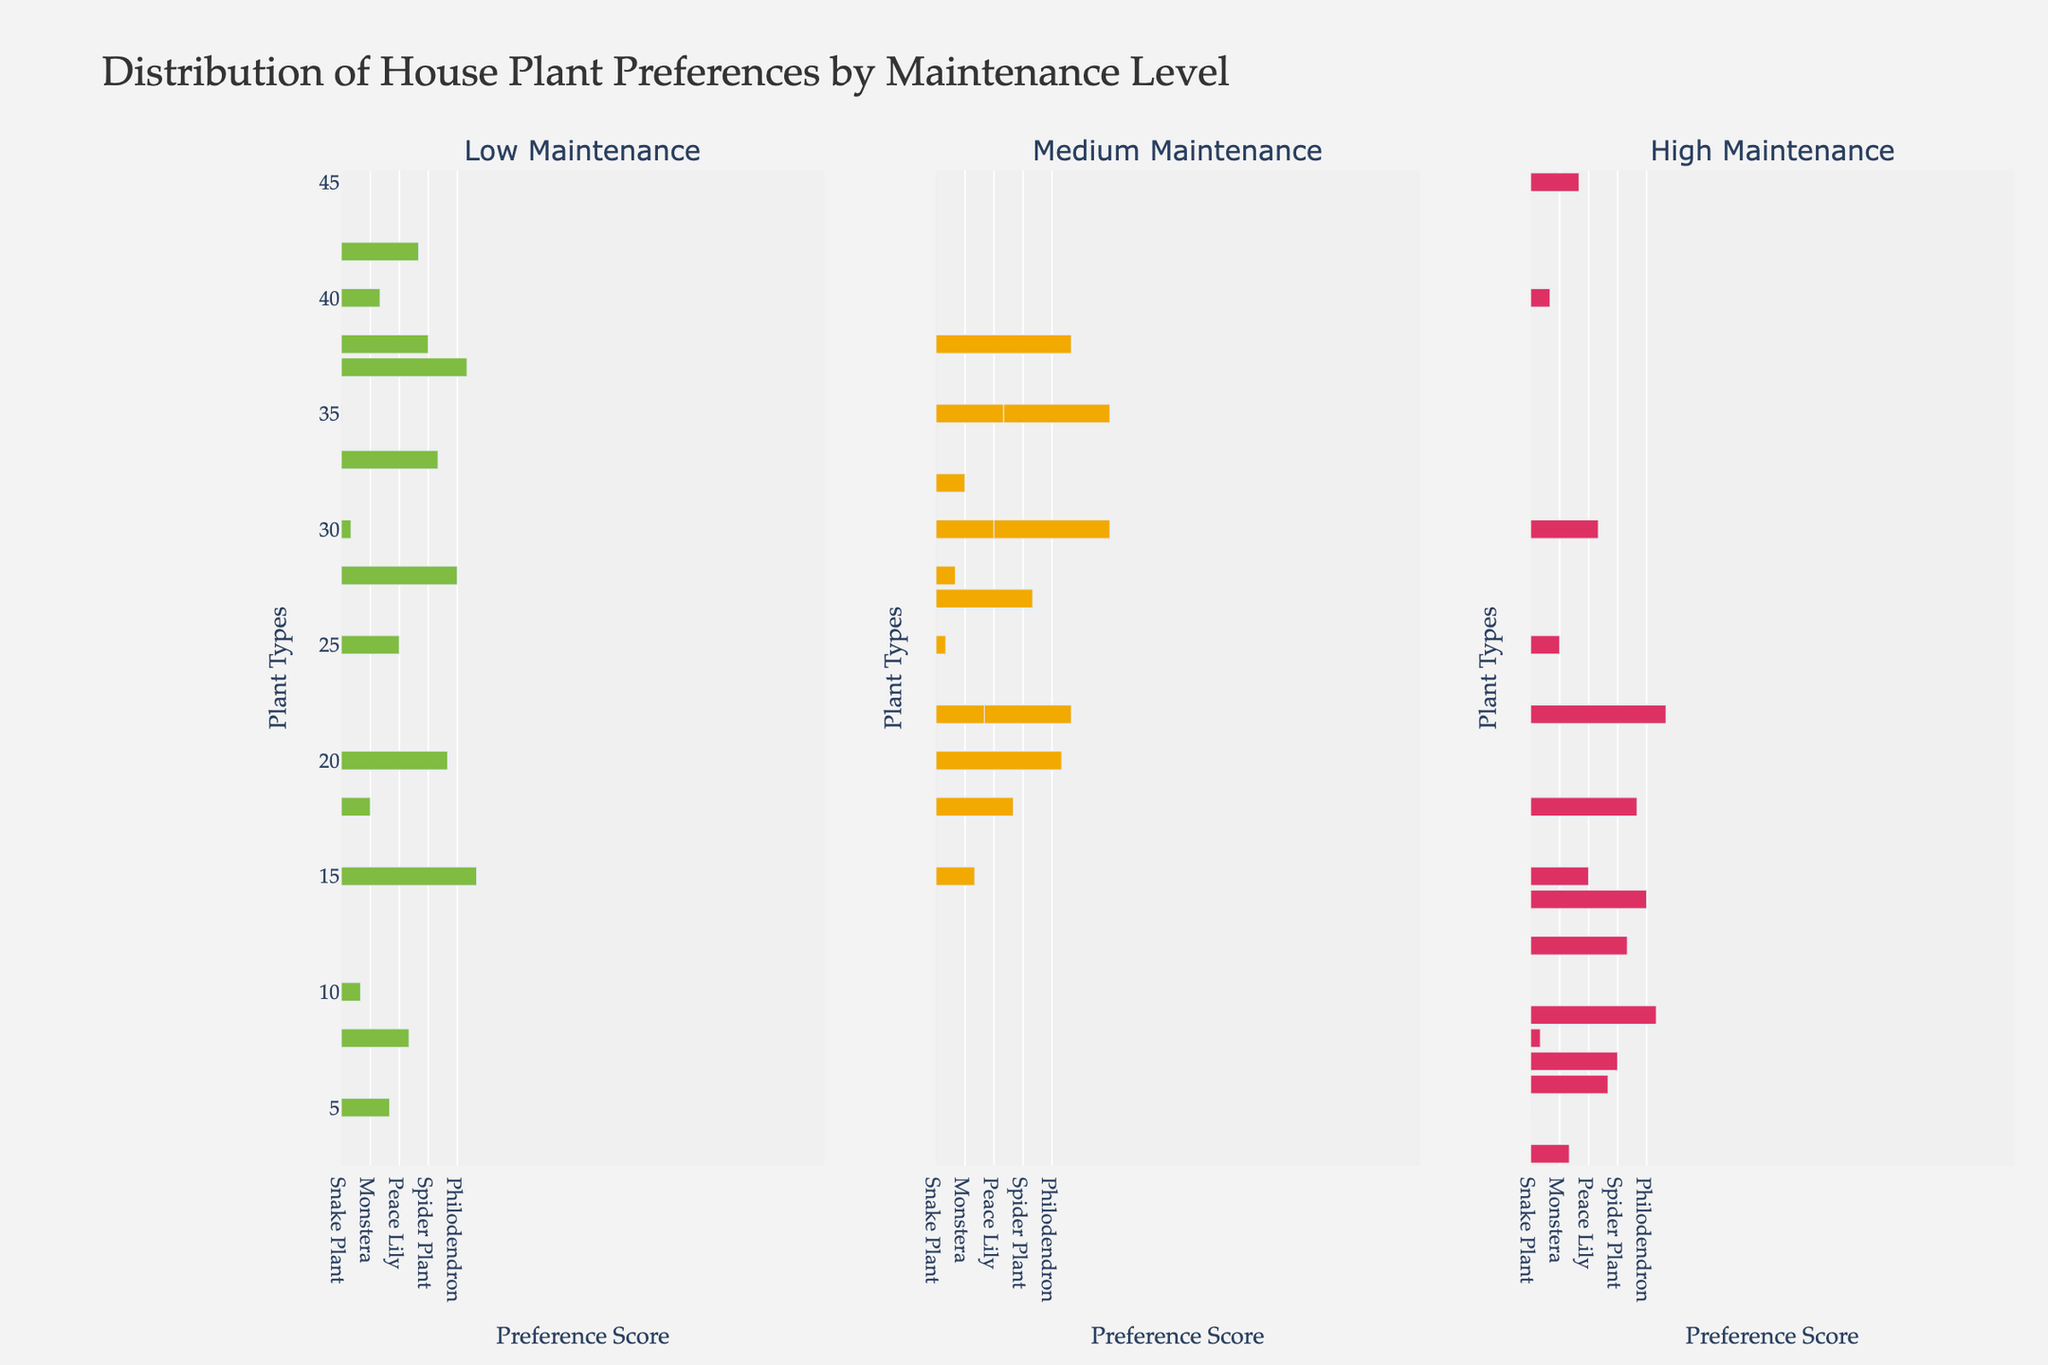What plant type is preferred most by people who want low maintenance plants? Look at the "Low Maintenance" column and find the highest bar. The highest preference score for low maintenance plants is for Succulents.
Answer: Succulents Which plant type has almost equal preferences for all three maintenance levels? Compare the heights of the bars across all three subplots for each plant type. The Pothos plant type has roughly similar heights across all three maintenance levels (30, 25, and 8).
Answer: Pothos How many more homeowners prefer ZZ Plant over Boston Fern for low maintenance? Find the heights of the bars for "ZZ Plant" and "Boston Fern" in the "Low Maintenance" subplot. The ZZ Plant has a height of 40, and the Boston Fern has a height of 8. Calculate the difference (40 - 8).
Answer: 32 Which plant type has the highest preference score in the Medium Maintenance category? Look at the "Medium Maintenance" subplot and find the highest bar. The highest preference score for medium maintenance plants is for Bamboo Palm.
Answer: Bamboo Palm What is the sum of the maintenance scores for Snake Plant across all levels? Add the scores from the "Low Maintenance" (35), "Medium Maintenance" (20), and "High Maintenance" (5) subplots for Snake Plant. 35 + 20 + 5 = 60
Answer: 60 Is the preference for Orchid greater in the Medium Maintenance or High Maintenance category? Compare the heights of the bars for "Orchid" in the "Medium Maintenance" and "High Maintenance" subplots. The height for the Medium Maintenance is 22, and the height for the High Maintenance is 45.
Answer: High Maintenance Which plant type has the least preference in the Low Maintenance category? Find the plant type with the shortest bar in the "Low Maintenance" subplot. The shortest bar corresponds to Orchid, with a preference score of 5.
Answer: Orchid Calculate the average preference score for Air Plants across all maintenance levels. Sum the preference scores for Air Plants: Low (33), Medium (27), and High (12). The sum is 33 + 27 + 12 = 72. Divide the sum by the number of maintenance levels (3). So, 72 / 3 = 24.
Answer: 24 Do more homeowners prefer Fiddle Leaf Fig or Monstera in the High Maintenance category? Compare the heights of the bars for "Fiddle Leaf Fig" and "Monstera" in the "High Maintenance" subplot. The height for Fiddle Leaf Fig is 40, and for Monstera, it is 25.
Answer: Fiddle Leaf Fig 